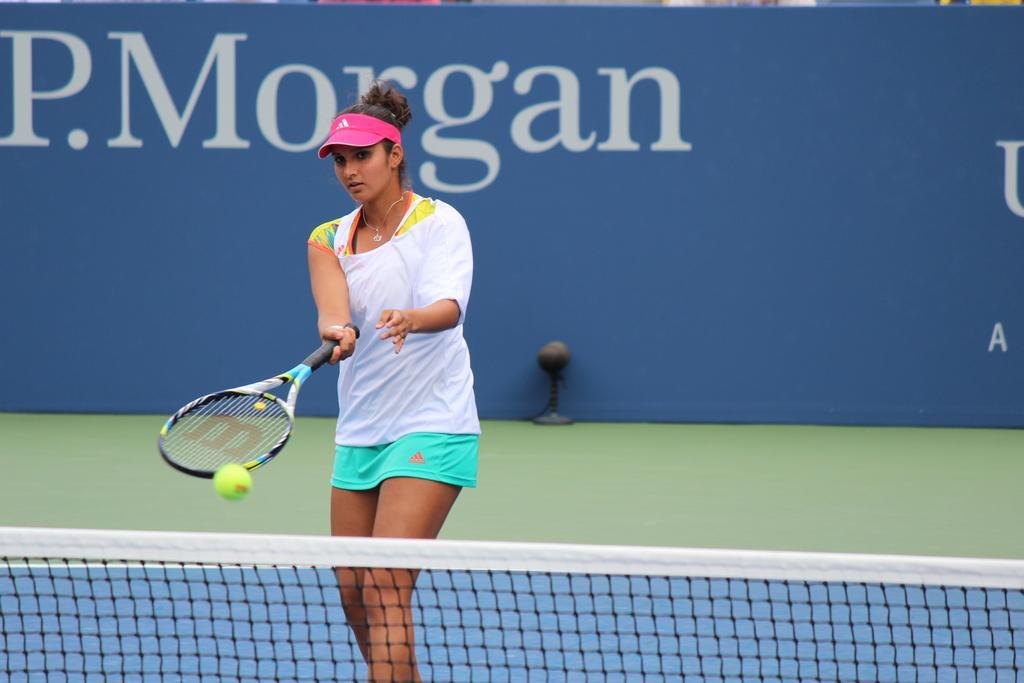In one or two sentences, can you explain what this image depicts? Here I can see a woman standing, holding a bat in the hand and playing the Tennis. At the bottom there is a net. In the background there is a blue color board on which I can see the text. 